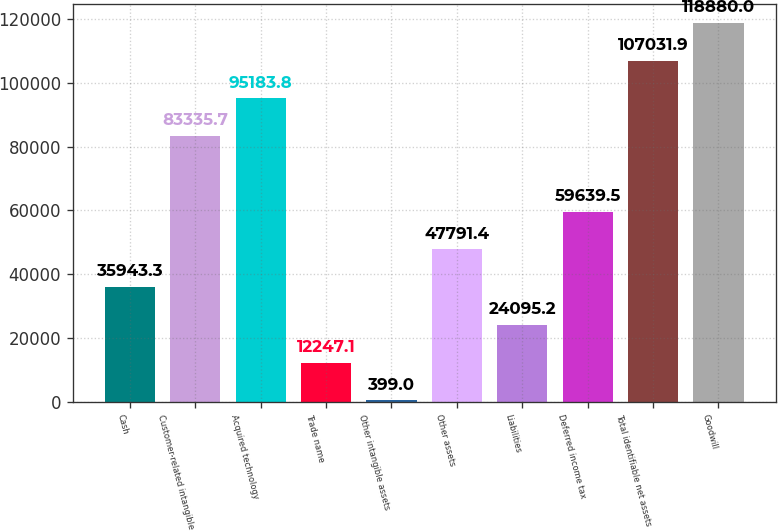Convert chart to OTSL. <chart><loc_0><loc_0><loc_500><loc_500><bar_chart><fcel>Cash<fcel>Customer-related intangible<fcel>Acquired technology<fcel>Trade name<fcel>Other intangible assets<fcel>Other assets<fcel>Liabilities<fcel>Deferred income tax<fcel>Total identifiable net assets<fcel>Goodwill<nl><fcel>35943.3<fcel>83335.7<fcel>95183.8<fcel>12247.1<fcel>399<fcel>47791.4<fcel>24095.2<fcel>59639.5<fcel>107032<fcel>118880<nl></chart> 